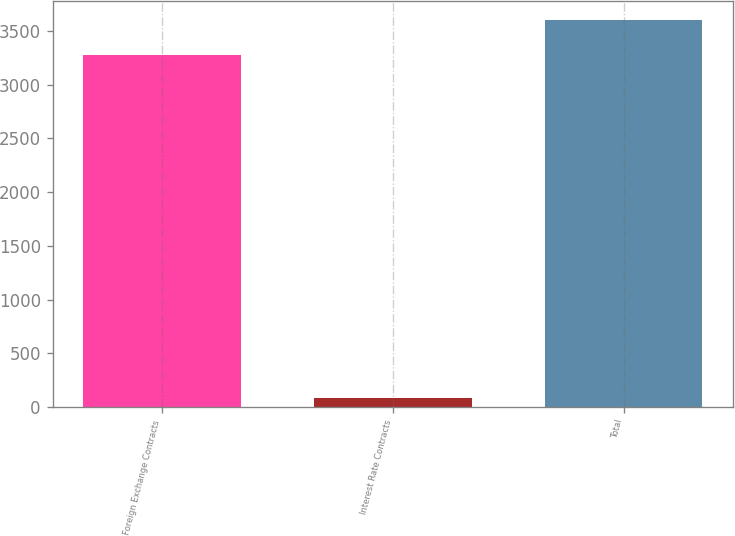Convert chart to OTSL. <chart><loc_0><loc_0><loc_500><loc_500><bar_chart><fcel>Foreign Exchange Contracts<fcel>Interest Rate Contracts<fcel>Total<nl><fcel>3274.2<fcel>87<fcel>3601.62<nl></chart> 